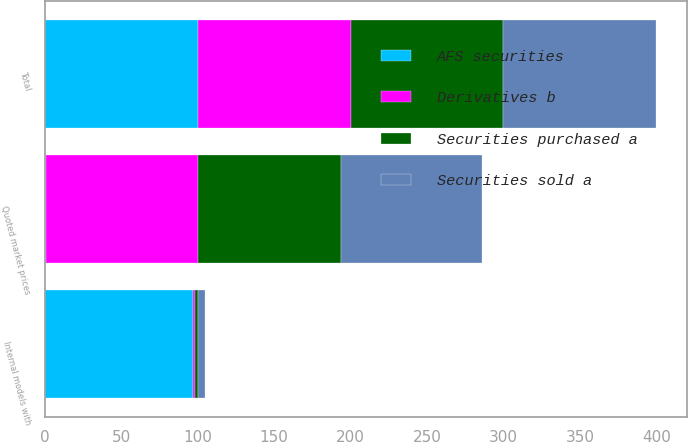Convert chart. <chart><loc_0><loc_0><loc_500><loc_500><stacked_bar_chart><ecel><fcel>Quoted market prices<fcel>Internal models with<fcel>Total<nl><fcel>Securities sold a<fcel>92<fcel>5<fcel>100<nl><fcel>AFS securities<fcel>1<fcel>97<fcel>100<nl><fcel>Derivatives b<fcel>99<fcel>1<fcel>100<nl><fcel>Securities purchased a<fcel>94<fcel>2<fcel>100<nl></chart> 